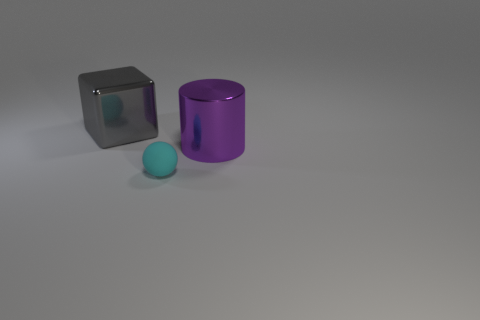What size is the cylinder that is made of the same material as the big gray thing?
Provide a short and direct response. Large. Is the size of the gray metallic object the same as the purple metallic cylinder?
Make the answer very short. Yes. Are any large gray balls visible?
Give a very brief answer. No. How big is the thing behind the metal thing in front of the metal object behind the big purple shiny cylinder?
Offer a terse response. Large. What number of cylinders are the same material as the large block?
Offer a terse response. 1. How many metal things are the same size as the purple metallic cylinder?
Your answer should be very brief. 1. What is the material of the big thing that is right of the big thing on the left side of the metal object on the right side of the tiny cyan matte object?
Offer a terse response. Metal. What number of objects are big purple matte cubes or large things?
Make the answer very short. 2. Is there any other thing that is the same material as the cyan ball?
Your answer should be compact. No. What is the shape of the tiny cyan object?
Your response must be concise. Sphere. 